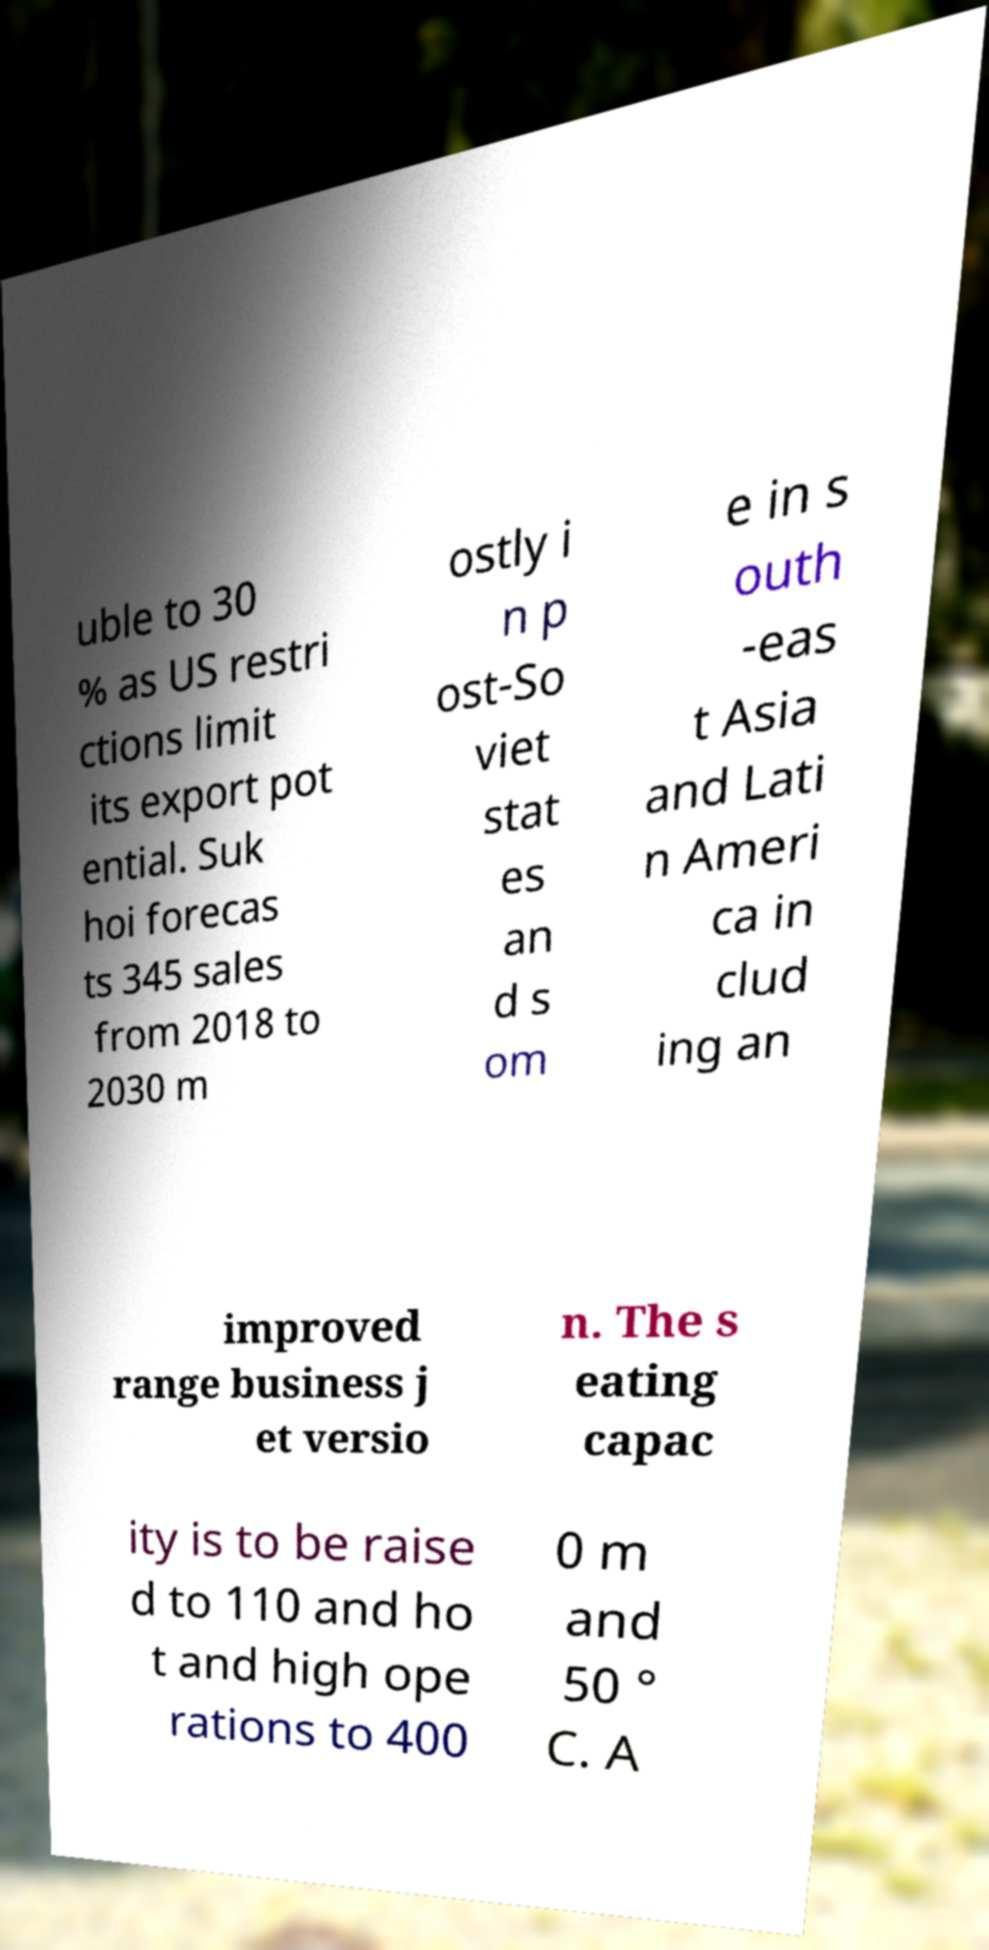Could you assist in decoding the text presented in this image and type it out clearly? uble to 30 % as US restri ctions limit its export pot ential. Suk hoi forecas ts 345 sales from 2018 to 2030 m ostly i n p ost-So viet stat es an d s om e in s outh -eas t Asia and Lati n Ameri ca in clud ing an improved range business j et versio n. The s eating capac ity is to be raise d to 110 and ho t and high ope rations to 400 0 m and 50 ° C. A 